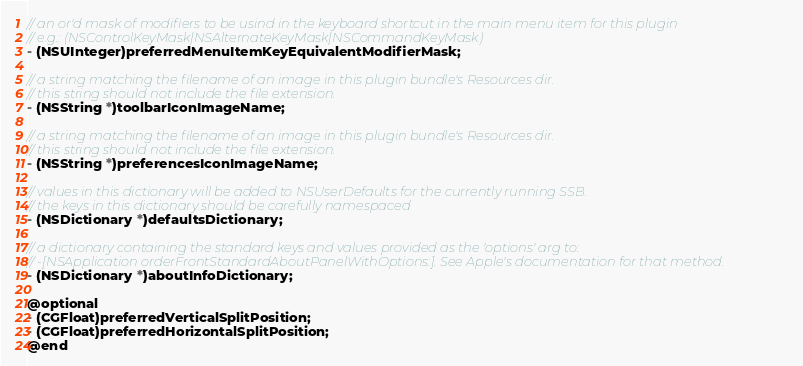<code> <loc_0><loc_0><loc_500><loc_500><_C_>// an or'd mask of modifiers to be usind in the keyboard shortcut in the main menu item for this plugin
// e.g.: (NSControlKeyMask|NSAlternateKeyMask|NSCommandKeyMask)
- (NSUInteger)preferredMenuItemKeyEquivalentModifierMask;

// a string matching the filename of an image in this plugin bundle's Resources dir.
// this string should not include the file extension.
- (NSString *)toolbarIconImageName;

// a string matching the filename of an image in this plugin bundle's Resources dir.
// this string should not include the file extension.
- (NSString *)preferencesIconImageName;

// values in this dictionary will be added to NSUserDefaults for the currently running SSB.
// the keys in this dictionary should be carefully namespaced
- (NSDictionary *)defaultsDictionary;

// a dictionary containing the standard keys and values provided as the 'options' arg to:
// -[NSApplication orderFrontStandardAboutPanelWithOptions:]. See Apple's documentation for that method.
- (NSDictionary *)aboutInfoDictionary;

@optional
- (CGFloat)preferredVerticalSplitPosition;
- (CGFloat)preferredHorizontalSplitPosition;
@end
</code> 